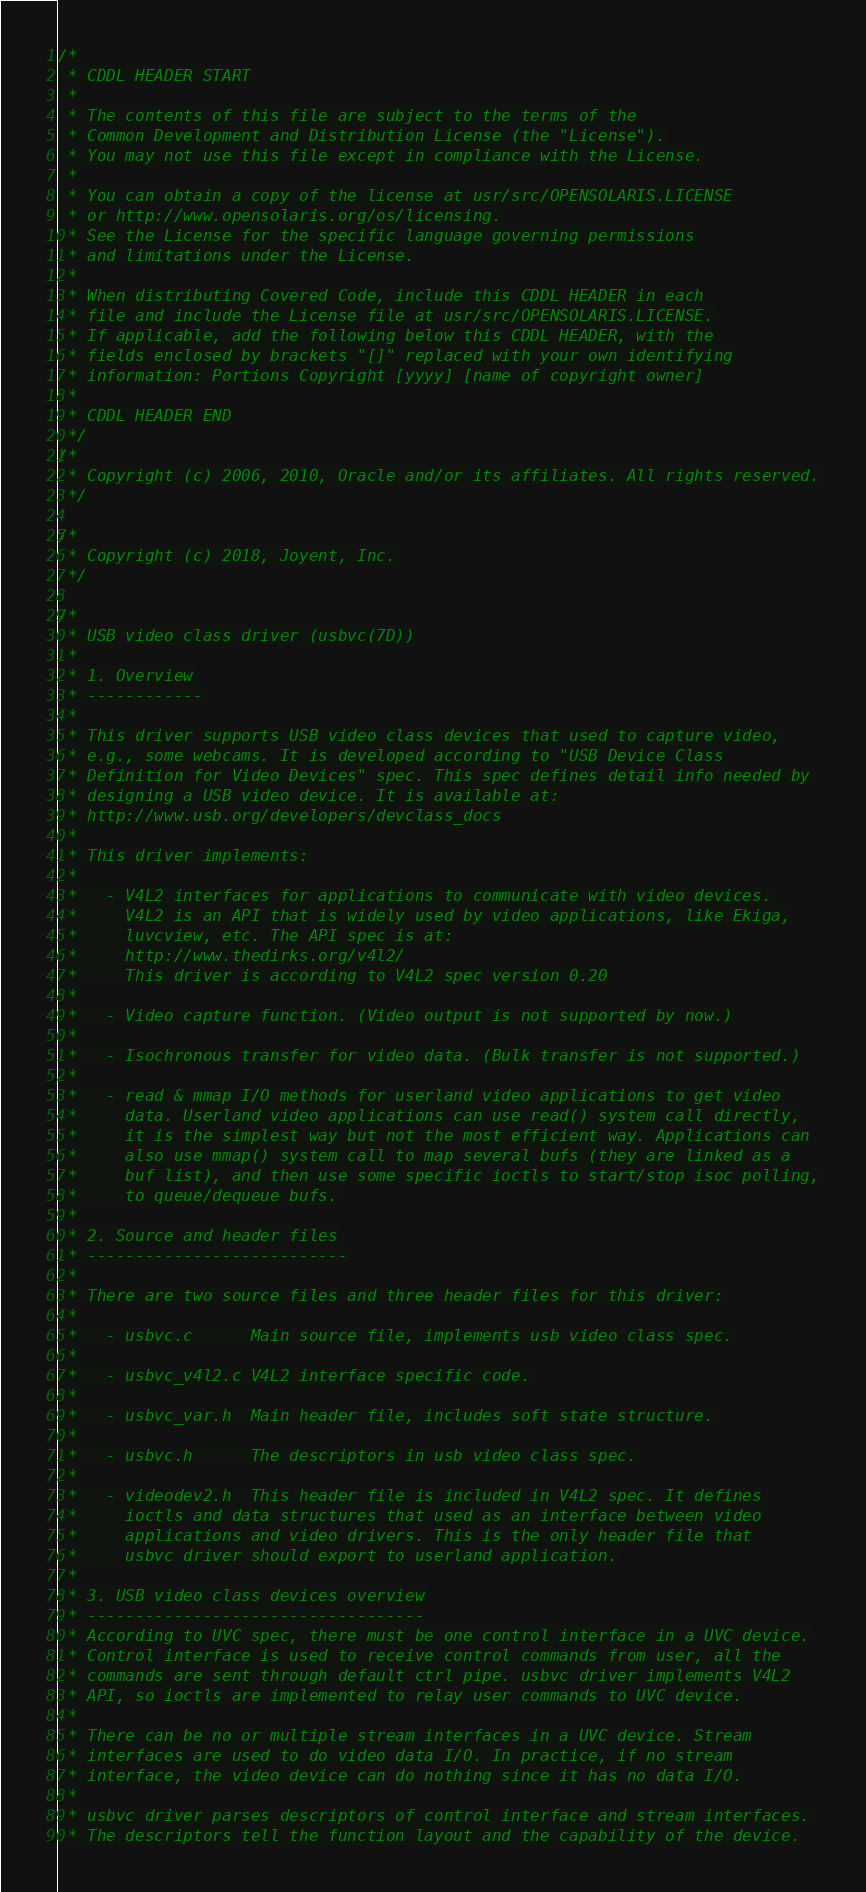Convert code to text. <code><loc_0><loc_0><loc_500><loc_500><_C_>/*
 * CDDL HEADER START
 *
 * The contents of this file are subject to the terms of the
 * Common Development and Distribution License (the "License").
 * You may not use this file except in compliance with the License.
 *
 * You can obtain a copy of the license at usr/src/OPENSOLARIS.LICENSE
 * or http://www.opensolaris.org/os/licensing.
 * See the License for the specific language governing permissions
 * and limitations under the License.
 *
 * When distributing Covered Code, include this CDDL HEADER in each
 * file and include the License file at usr/src/OPENSOLARIS.LICENSE.
 * If applicable, add the following below this CDDL HEADER, with the
 * fields enclosed by brackets "[]" replaced with your own identifying
 * information: Portions Copyright [yyyy] [name of copyright owner]
 *
 * CDDL HEADER END
 */
/*
 * Copyright (c) 2006, 2010, Oracle and/or its affiliates. All rights reserved.
 */

/*
 * Copyright (c) 2018, Joyent, Inc.
 */

/*
 * USB video class driver (usbvc(7D))
 *
 * 1. Overview
 * ------------
 *
 * This driver supports USB video class devices that used to capture video,
 * e.g., some webcams. It is developed according to "USB Device Class
 * Definition for Video Devices" spec. This spec defines detail info needed by
 * designing a USB video device. It is available at:
 * http://www.usb.org/developers/devclass_docs
 *
 * This driver implements:
 *
 *   - V4L2 interfaces for applications to communicate with video devices.
 *     V4L2 is an API that is widely used by video applications, like Ekiga,
 *     luvcview, etc. The API spec is at:
 *     http://www.thedirks.org/v4l2/
 *     This driver is according to V4L2 spec version 0.20
 *
 *   - Video capture function. (Video output is not supported by now.)
 *
 *   - Isochronous transfer for video data. (Bulk transfer is not supported.)
 *
 *   - read & mmap I/O methods for userland video applications to get video
 *     data. Userland video applications can use read() system call directly,
 *     it is the simplest way but not the most efficient way. Applications can
 *     also use mmap() system call to map several bufs (they are linked as a
 *     buf list), and then use some specific ioctls to start/stop isoc polling,
 *     to queue/dequeue bufs.
 *
 * 2. Source and header files
 * ---------------------------
 *
 * There are two source files and three header files for this driver:
 *
 *   - usbvc.c		Main source file, implements usb video class spec.
 *
 *   - usbvc_v4l2.c	V4L2 interface specific code.
 *
 *   - usbvc_var.h	Main header file, includes soft state structure.
 *
 *   - usbvc.h		The descriptors in usb video class spec.
 *
 *   - videodev2.h	This header file is included in V4L2 spec. It defines
 *     ioctls and data structures that used as an interface between video
 *     applications and video drivers. This is the only header file that
 *     usbvc driver should export to userland application.
 *
 * 3. USB video class devices overview
 * -----------------------------------
 * According to UVC spec, there must be one control interface in a UVC device.
 * Control interface is used to receive control commands from user, all the
 * commands are sent through default ctrl pipe. usbvc driver implements V4L2
 * API, so ioctls are implemented to relay user commands to UVC device.
 *
 * There can be no or multiple stream interfaces in a UVC device. Stream
 * interfaces are used to do video data I/O. In practice, if no stream
 * interface, the video device can do nothing since it has no data I/O.
 *
 * usbvc driver parses descriptors of control interface and stream interfaces.
 * The descriptors tell the function layout and the capability of the device.</code> 